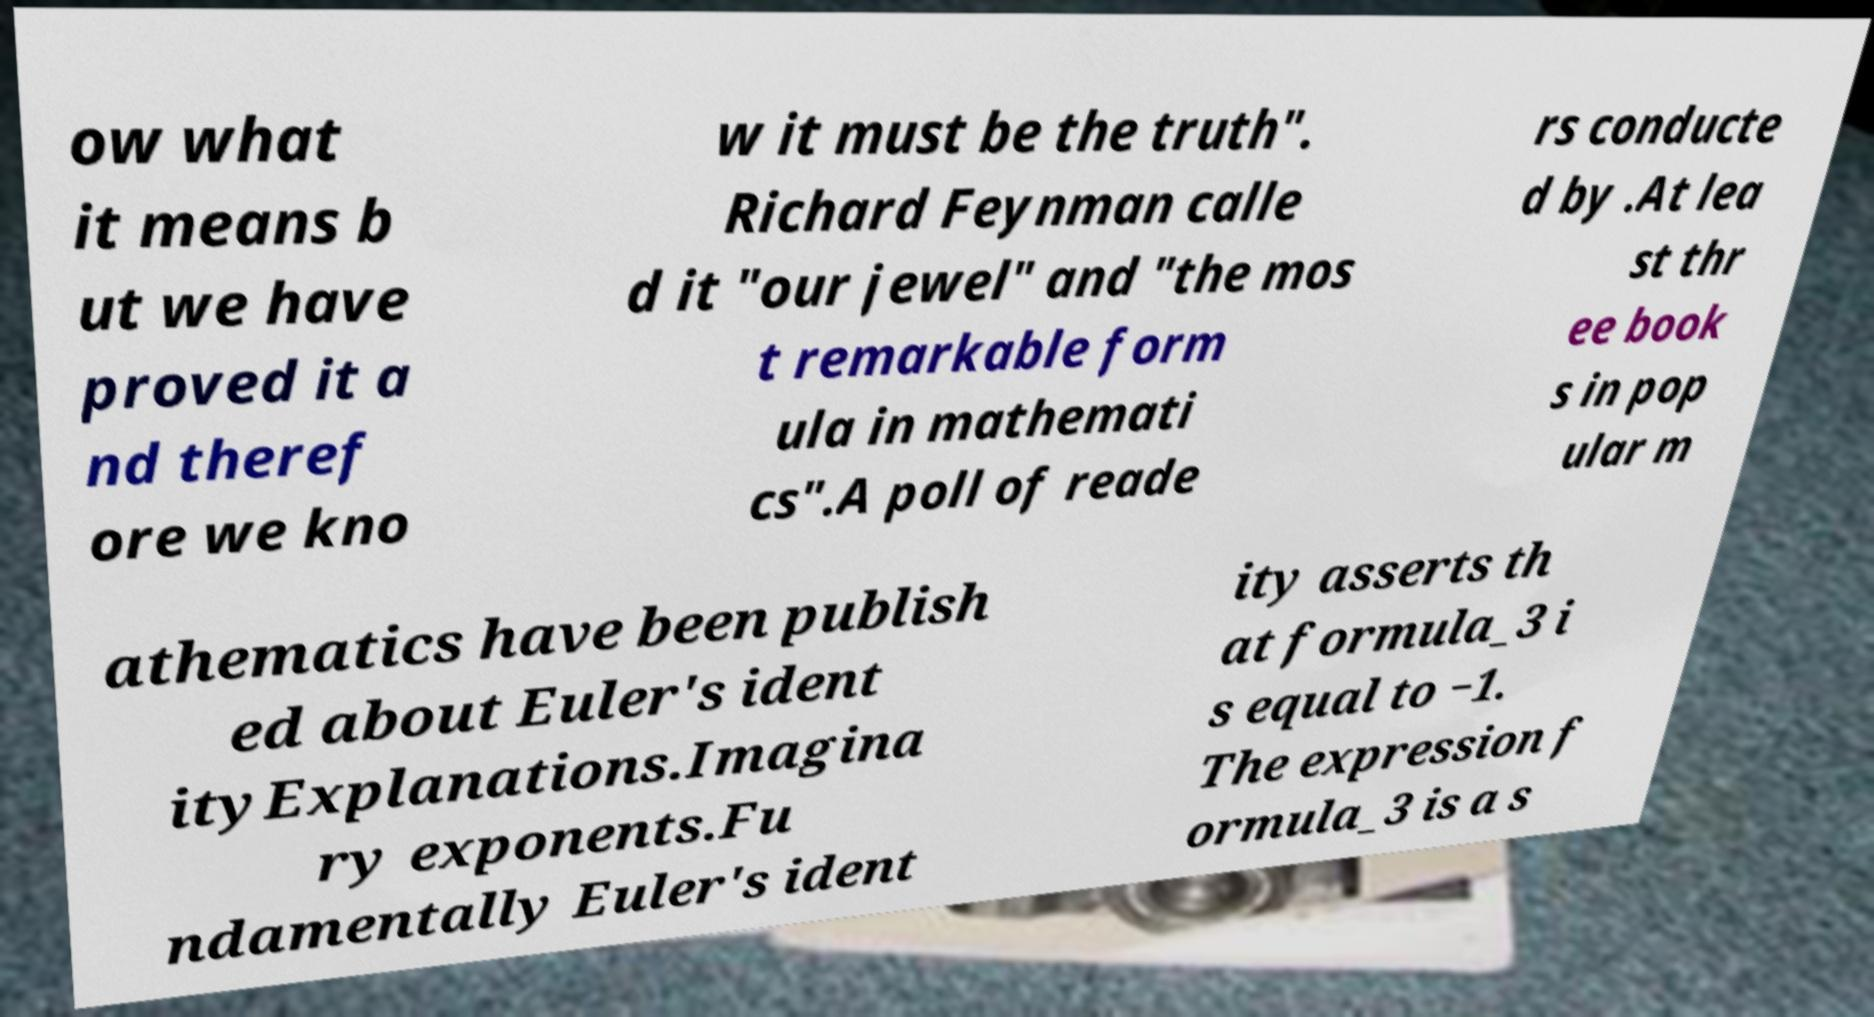There's text embedded in this image that I need extracted. Can you transcribe it verbatim? ow what it means b ut we have proved it a nd theref ore we kno w it must be the truth". Richard Feynman calle d it "our jewel" and "the mos t remarkable form ula in mathemati cs".A poll of reade rs conducte d by .At lea st thr ee book s in pop ular m athematics have been publish ed about Euler's ident ityExplanations.Imagina ry exponents.Fu ndamentally Euler's ident ity asserts th at formula_3 i s equal to −1. The expression f ormula_3 is a s 